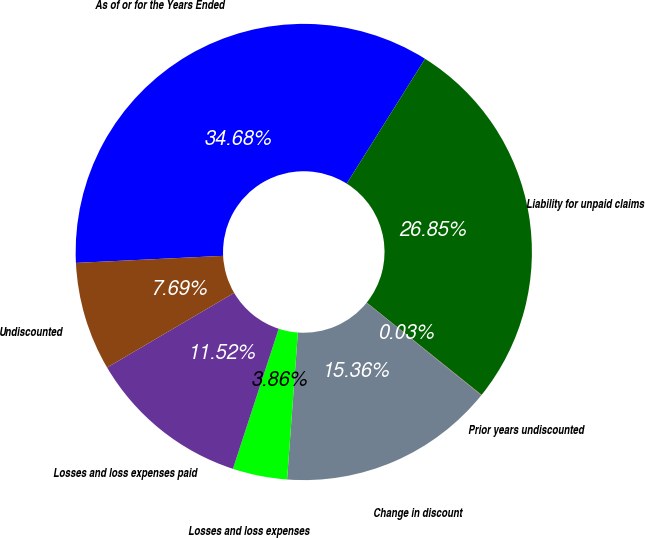<chart> <loc_0><loc_0><loc_500><loc_500><pie_chart><fcel>As of or for the Years Ended<fcel>Liability for unpaid claims<fcel>Prior years undiscounted<fcel>Change in discount<fcel>Losses and loss expenses<fcel>Losses and loss expenses paid<fcel>Undiscounted<nl><fcel>34.68%<fcel>26.85%<fcel>0.03%<fcel>15.36%<fcel>3.86%<fcel>11.52%<fcel>7.69%<nl></chart> 